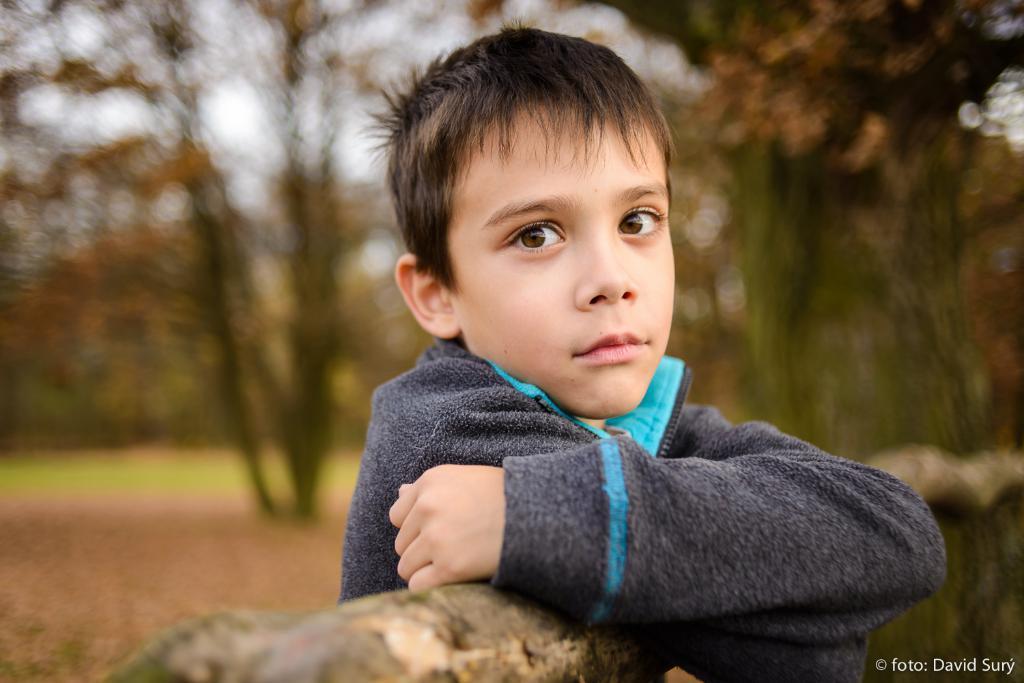Could you give a brief overview of what you see in this image? In this image, we can see a person and the wall. We can see some text on the bottom right corner. We can also see the blurred background. 